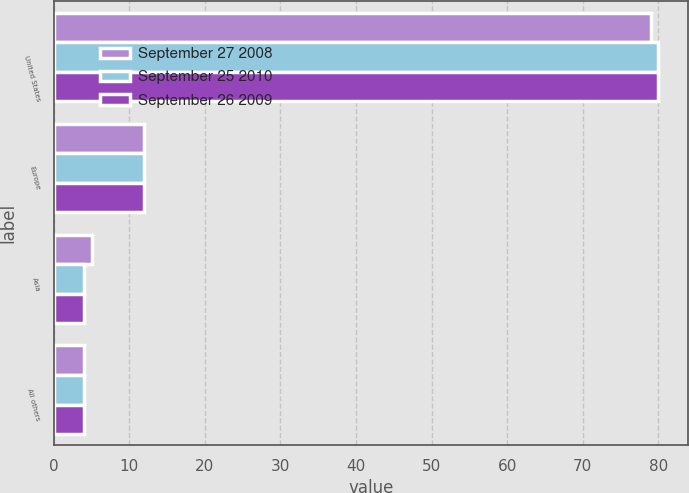Convert chart to OTSL. <chart><loc_0><loc_0><loc_500><loc_500><stacked_bar_chart><ecel><fcel>United States<fcel>Europe<fcel>Asia<fcel>All others<nl><fcel>September 27 2008<fcel>79<fcel>12<fcel>5<fcel>4<nl><fcel>September 25 2010<fcel>80<fcel>12<fcel>4<fcel>4<nl><fcel>September 26 2009<fcel>80<fcel>12<fcel>4<fcel>4<nl></chart> 